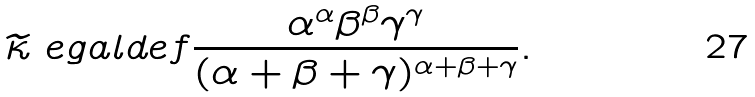<formula> <loc_0><loc_0><loc_500><loc_500>\widetilde { \kappa } \ e g a l d e f \frac { \alpha ^ { \alpha } \beta ^ { \beta } \gamma ^ { \gamma } } { ( \alpha + \beta + \gamma ) ^ { \alpha + \beta + \gamma } } .</formula> 